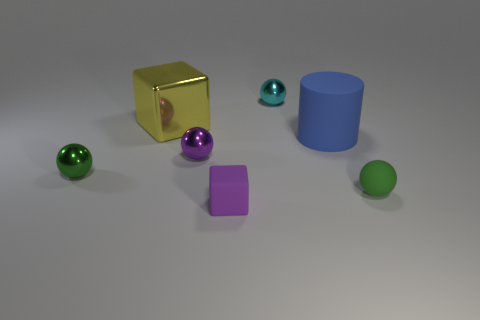Is there anything else that has the same shape as the blue thing?
Ensure brevity in your answer.  No. What is the material of the small cyan object that is the same shape as the purple metallic thing?
Offer a very short reply. Metal. How many objects are shiny things that are on the right side of the small green metal sphere or tiny shiny objects that are behind the tiny green shiny object?
Ensure brevity in your answer.  3. Is the color of the matte cube the same as the small shiny object that is on the right side of the matte cube?
Provide a succinct answer. No. There is a big yellow thing that is the same material as the cyan ball; what shape is it?
Keep it short and to the point. Cube. How many cyan shiny balls are there?
Provide a short and direct response. 1. What number of things are metal spheres that are behind the yellow cube or large brown metal cylinders?
Provide a succinct answer. 1. There is a tiny metallic sphere left of the big cube; is it the same color as the tiny rubber sphere?
Provide a succinct answer. Yes. How many other things are the same color as the cylinder?
Ensure brevity in your answer.  0. What number of tiny things are purple matte objects or purple balls?
Offer a very short reply. 2. 